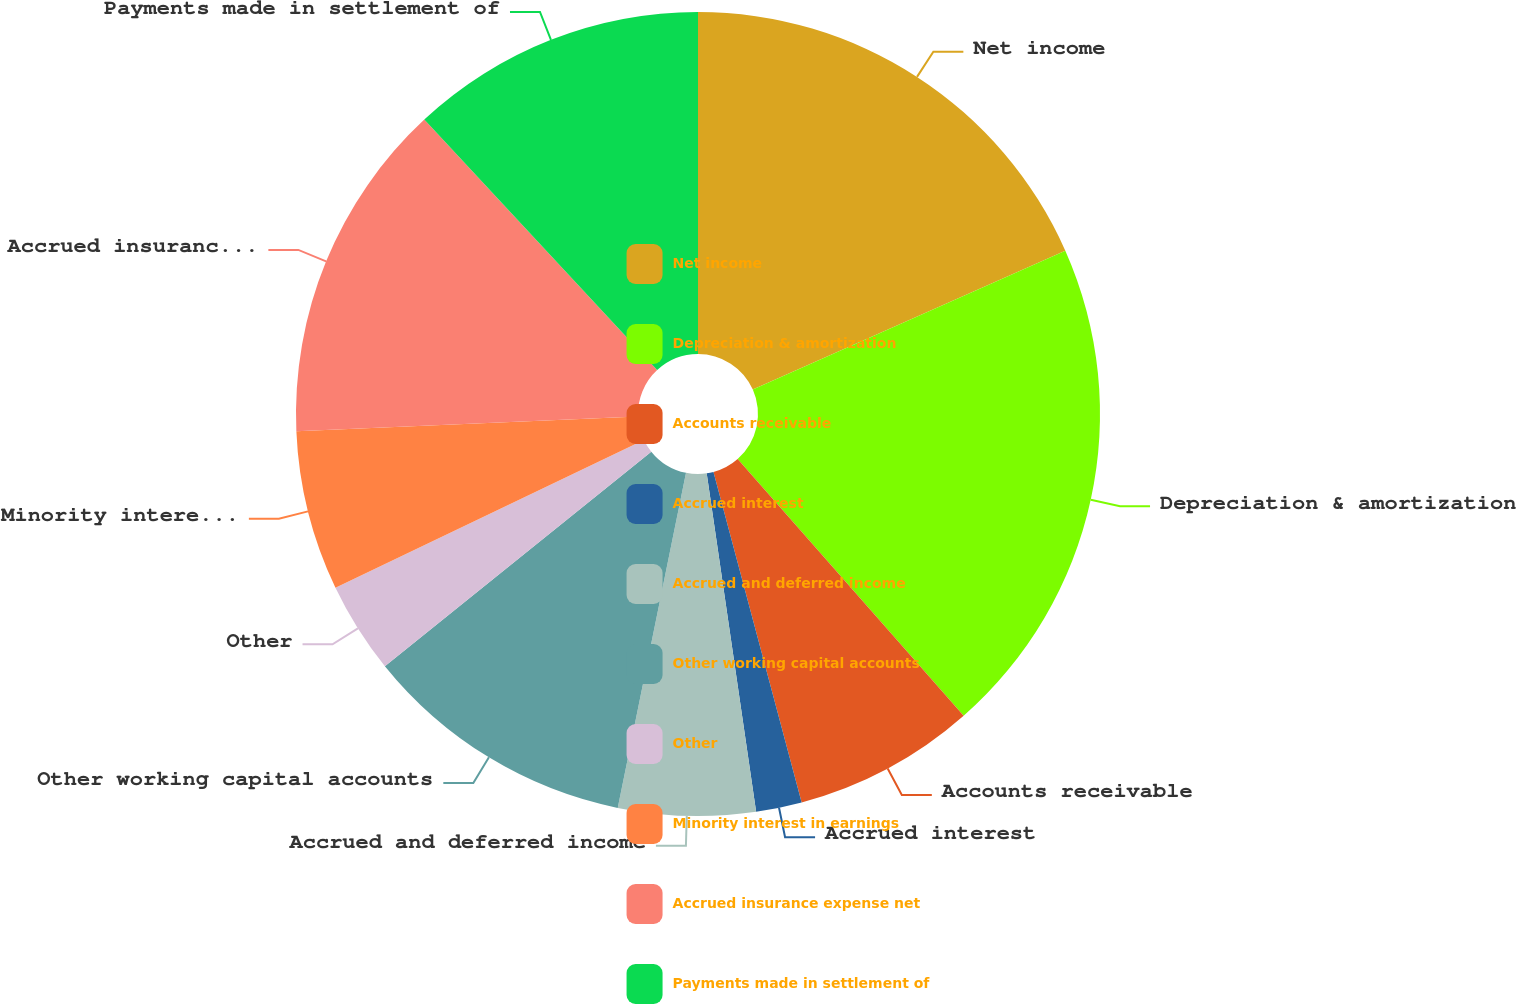<chart> <loc_0><loc_0><loc_500><loc_500><pie_chart><fcel>Net income<fcel>Depreciation & amortization<fcel>Accounts receivable<fcel>Accrued interest<fcel>Accrued and deferred income<fcel>Other working capital accounts<fcel>Other<fcel>Minority interest in earnings<fcel>Accrued insurance expense net<fcel>Payments made in settlement of<nl><fcel>18.34%<fcel>20.17%<fcel>7.34%<fcel>1.84%<fcel>5.51%<fcel>11.01%<fcel>3.68%<fcel>6.43%<fcel>13.76%<fcel>11.92%<nl></chart> 